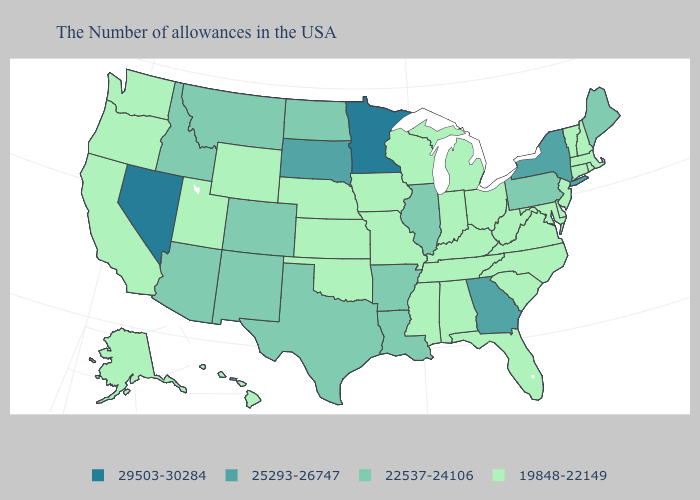Is the legend a continuous bar?
Be succinct. No. Name the states that have a value in the range 19848-22149?
Short answer required. Massachusetts, Rhode Island, New Hampshire, Vermont, Connecticut, New Jersey, Delaware, Maryland, Virginia, North Carolina, South Carolina, West Virginia, Ohio, Florida, Michigan, Kentucky, Indiana, Alabama, Tennessee, Wisconsin, Mississippi, Missouri, Iowa, Kansas, Nebraska, Oklahoma, Wyoming, Utah, California, Washington, Oregon, Alaska, Hawaii. Name the states that have a value in the range 22537-24106?
Keep it brief. Maine, Pennsylvania, Illinois, Louisiana, Arkansas, Texas, North Dakota, Colorado, New Mexico, Montana, Arizona, Idaho. Among the states that border New York , which have the lowest value?
Give a very brief answer. Massachusetts, Vermont, Connecticut, New Jersey. Among the states that border Oregon , does California have the highest value?
Keep it brief. No. What is the value of Idaho?
Be succinct. 22537-24106. Does the first symbol in the legend represent the smallest category?
Quick response, please. No. What is the value of Idaho?
Be succinct. 22537-24106. What is the highest value in the USA?
Keep it brief. 29503-30284. What is the lowest value in the West?
Be succinct. 19848-22149. What is the value of Kentucky?
Be succinct. 19848-22149. Name the states that have a value in the range 29503-30284?
Write a very short answer. Minnesota, Nevada. 